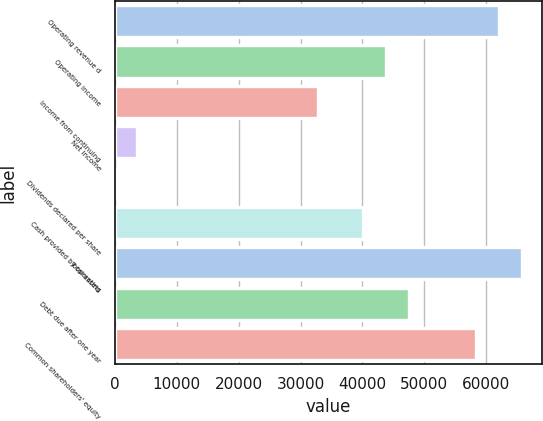Convert chart. <chart><loc_0><loc_0><loc_500><loc_500><bar_chart><fcel>Operating revenue d<fcel>Operating income<fcel>Income from continuing<fcel>Net income<fcel>Dividends declared per share<fcel>Cash provided by operating<fcel>Total assets<fcel>Debt due after one year<fcel>Common shareholders' equity<nl><fcel>62074.7<fcel>43817.8<fcel>32863.6<fcel>3652.58<fcel>1.2<fcel>40166.4<fcel>65726<fcel>47469.1<fcel>58423.3<nl></chart> 